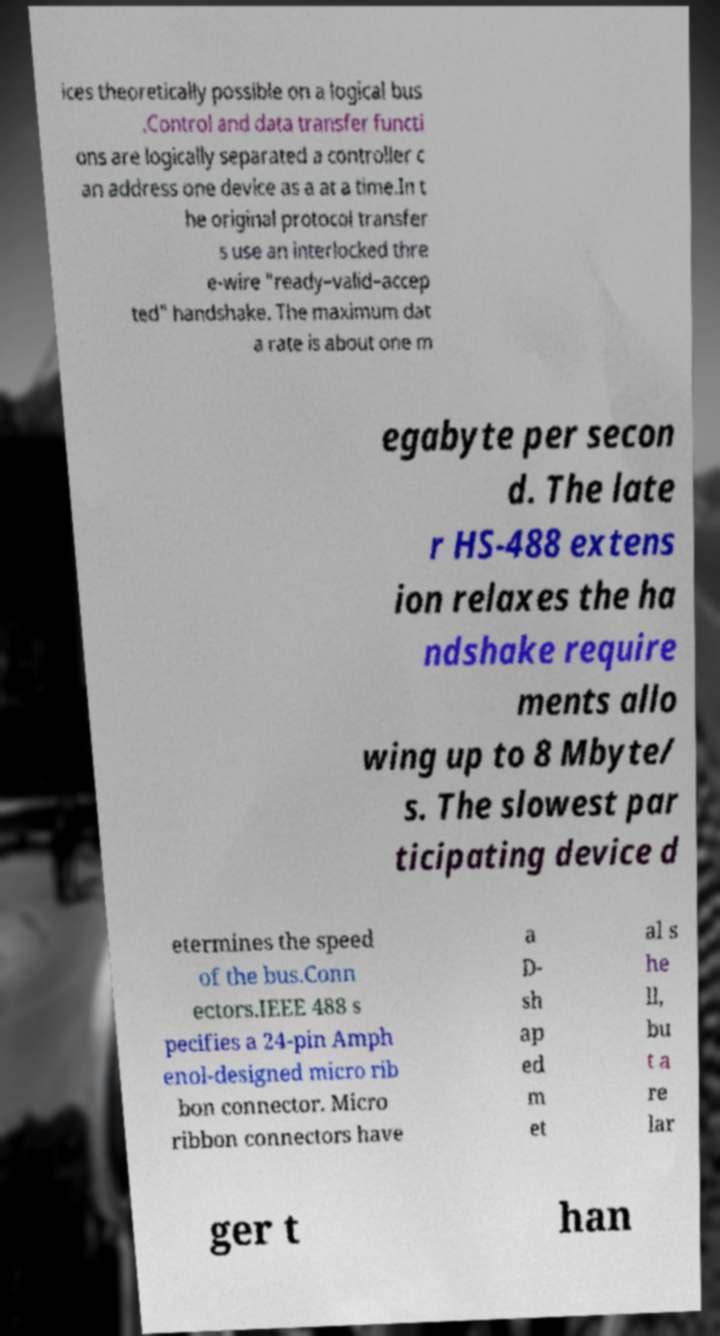Please read and relay the text visible in this image. What does it say? ices theoretically possible on a logical bus .Control and data transfer functi ons are logically separated a controller c an address one device as a at a time.In t he original protocol transfer s use an interlocked thre e-wire "ready–valid–accep ted" handshake. The maximum dat a rate is about one m egabyte per secon d. The late r HS-488 extens ion relaxes the ha ndshake require ments allo wing up to 8 Mbyte/ s. The slowest par ticipating device d etermines the speed of the bus.Conn ectors.IEEE 488 s pecifies a 24-pin Amph enol-designed micro rib bon connector. Micro ribbon connectors have a D- sh ap ed m et al s he ll, bu t a re lar ger t han 